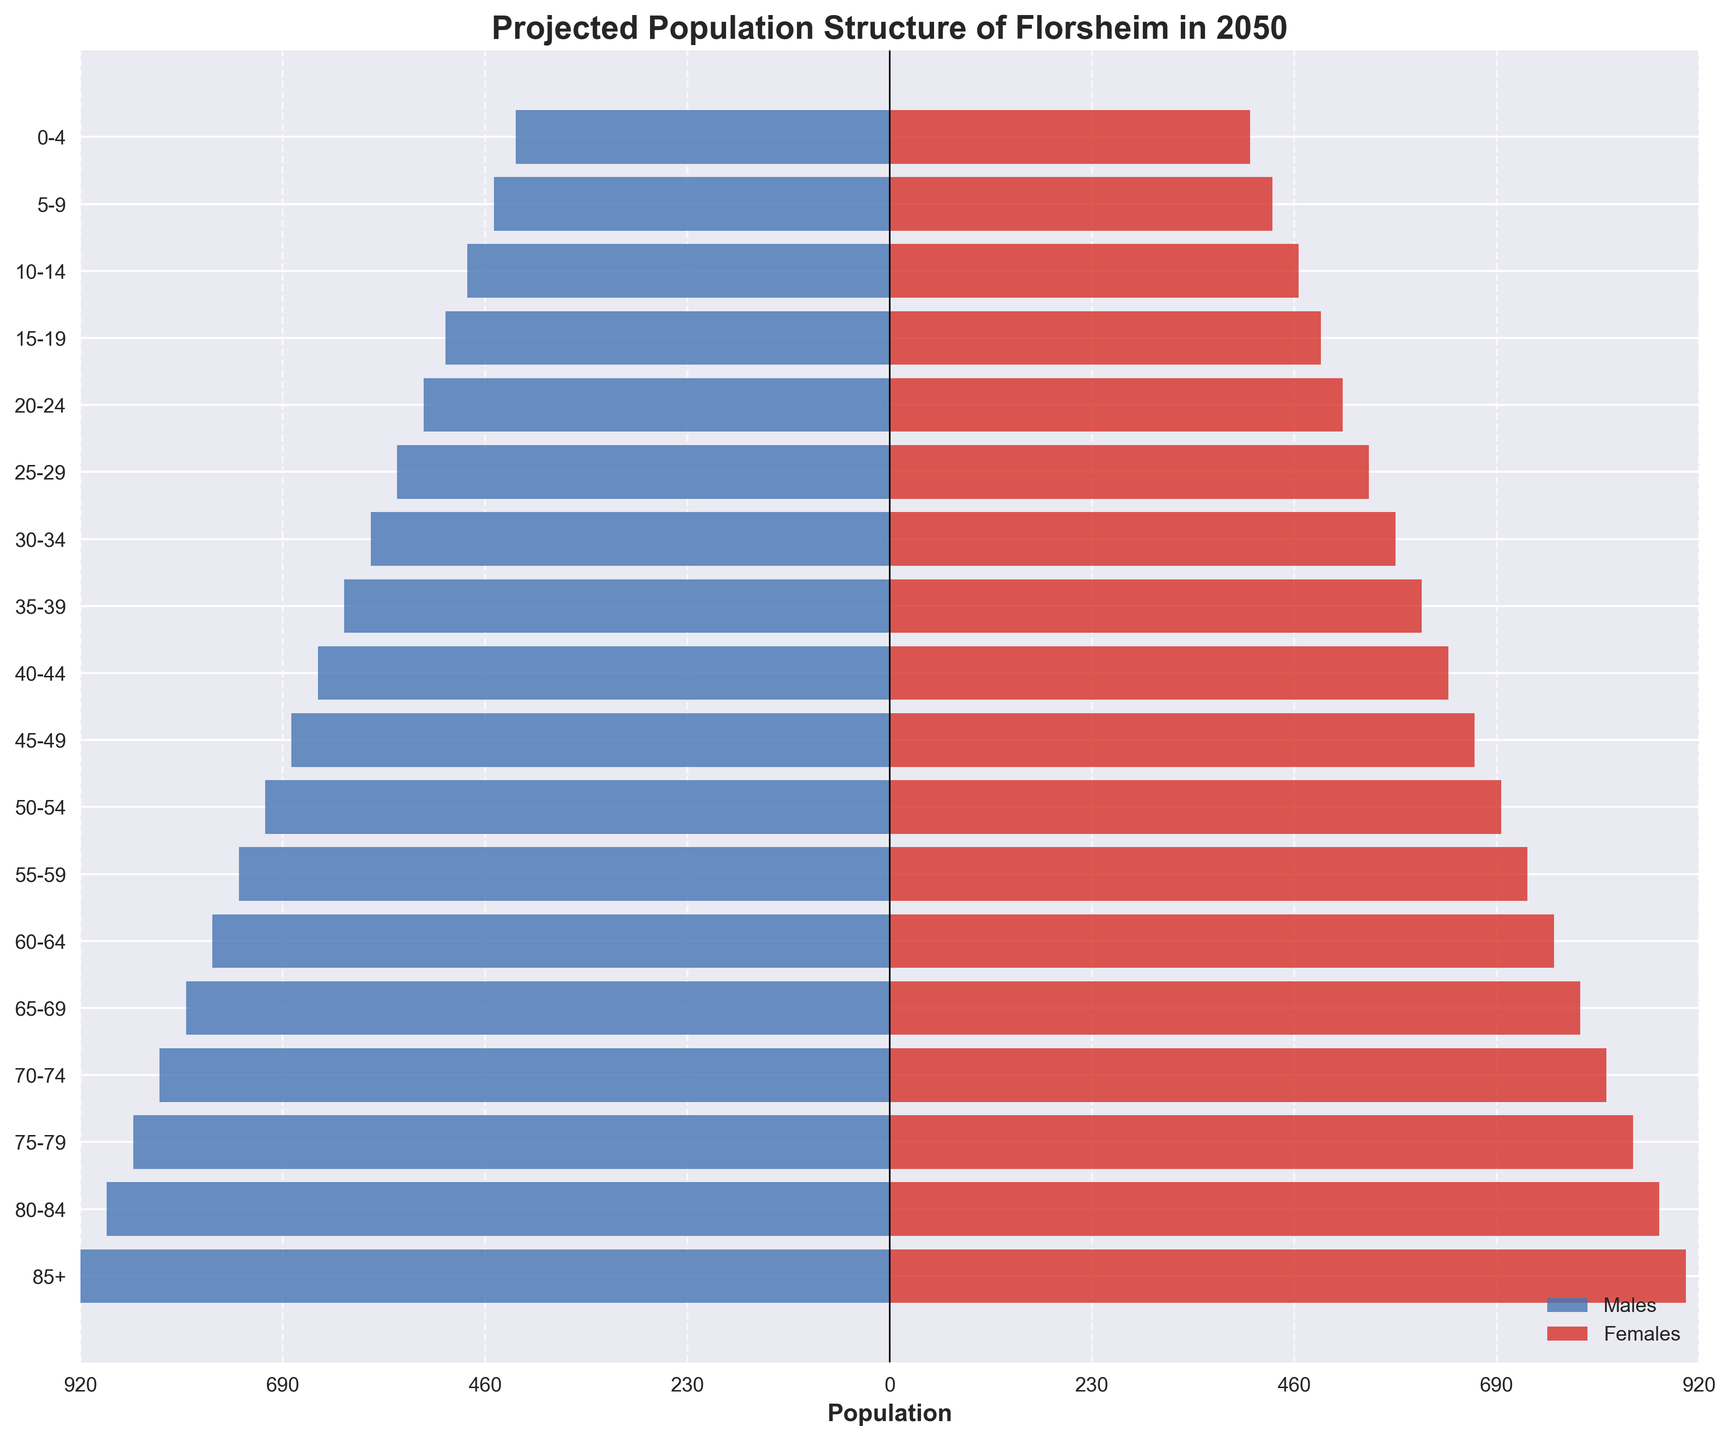What is the title of the plot? The title is placed at the top of the plot and typically describes the content of the figure. In this case, it indicates what the plot represents.
Answer: Projected Population Structure of Florsheim in 2050 Which age group has the highest number of individuals? To find this, compare the lengths of the bars for each age group, accounting for both males and females. The age group with the longest combined male and female bar is the answer.
Answer: 85+ How many more males are there than females in the 80-84 age group? Count the difference between the male and female bars for the 80-84 age group. Males have 890, and females have 875. Subtract females from males.
Answer: 15 What is the total population in the 25-29 age group? The total for 25-29 can be found by summing the male and female populations in that age group (560 males + 545 females).
Answer: 1105 Which gender has a higher population in the 50-54 age group? Compare the lengths of the male and female bars in the 50-54 age group. The bar that extends further indicates the gender with the higher population.
Answer: Males Is the population in the 0-4 age group higher or lower than the 75-79 age group? First, sum the males and females in both age groups: 0-4 (425 males + 410 females = 835), 75-79 (860 males + 845 females = 1705). Then compare the totals.
Answer: Lower What age group shows the least difference between male and female populations? Calculate the difference between male and female populations for each age group. Identify the age group with the smallest difference.
Answer: 85+ Which age group has the least number of males? Look for the shortest male bar across all age groups.
Answer: 0-4 What is the combined population of Florsheim for the age groups 35-39 and 45-49? Sum the male and female populations in the 35-39 and 45-49 age groups separately, then add these totals. 35-39 (620 males + 605 females = 1225), 45-49 (680 males + 665 females = 1345). Now sum the two results: 1225 + 1345.
Answer: 2570 Which age group shows the highest difference between male and female populations? Calculate the difference between male and female populations for each age group and identify the age group with the largest difference.
Answer: 85+ 